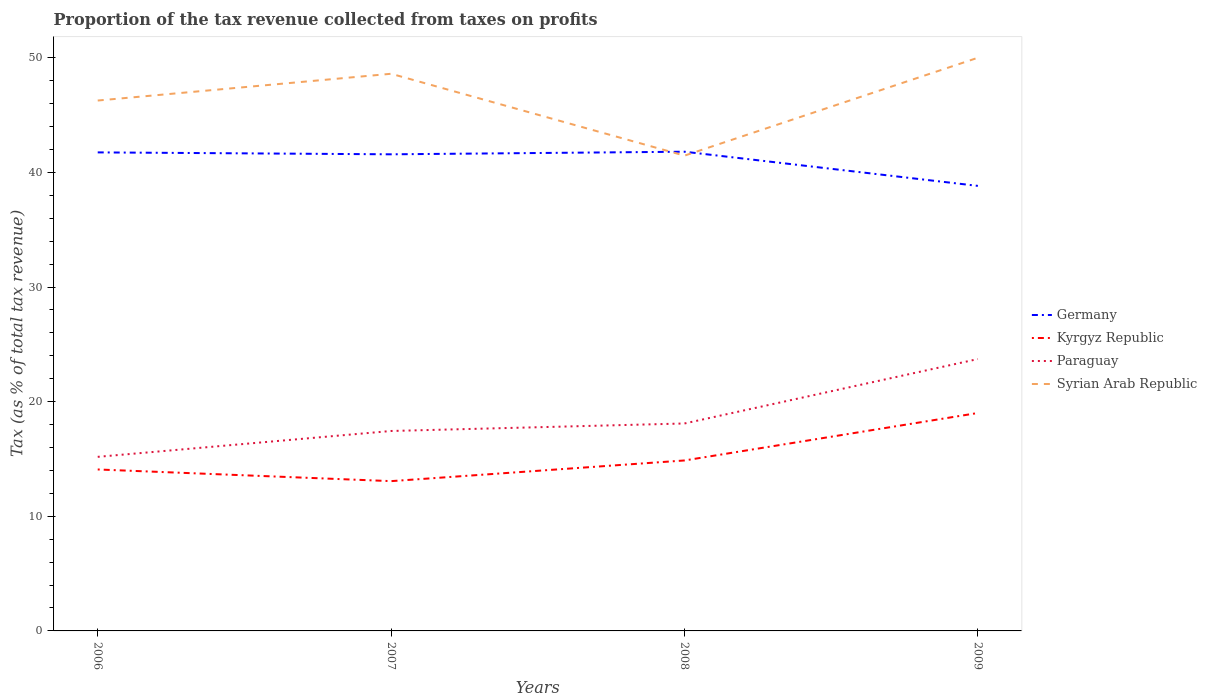Does the line corresponding to Syrian Arab Republic intersect with the line corresponding to Kyrgyz Republic?
Keep it short and to the point. No. Is the number of lines equal to the number of legend labels?
Provide a succinct answer. Yes. Across all years, what is the maximum proportion of the tax revenue collected in Paraguay?
Your answer should be compact. 15.19. In which year was the proportion of the tax revenue collected in Germany maximum?
Offer a terse response. 2009. What is the total proportion of the tax revenue collected in Kyrgyz Republic in the graph?
Your answer should be very brief. 1.02. What is the difference between the highest and the second highest proportion of the tax revenue collected in Syrian Arab Republic?
Give a very brief answer. 8.54. Is the proportion of the tax revenue collected in Paraguay strictly greater than the proportion of the tax revenue collected in Kyrgyz Republic over the years?
Make the answer very short. No. Are the values on the major ticks of Y-axis written in scientific E-notation?
Offer a terse response. No. Does the graph contain any zero values?
Offer a very short reply. No. Where does the legend appear in the graph?
Provide a succinct answer. Center right. How many legend labels are there?
Provide a succinct answer. 4. What is the title of the graph?
Your answer should be very brief. Proportion of the tax revenue collected from taxes on profits. What is the label or title of the X-axis?
Your response must be concise. Years. What is the label or title of the Y-axis?
Your answer should be compact. Tax (as % of total tax revenue). What is the Tax (as % of total tax revenue) of Germany in 2006?
Your answer should be very brief. 41.74. What is the Tax (as % of total tax revenue) in Kyrgyz Republic in 2006?
Ensure brevity in your answer.  14.08. What is the Tax (as % of total tax revenue) in Paraguay in 2006?
Ensure brevity in your answer.  15.19. What is the Tax (as % of total tax revenue) of Syrian Arab Republic in 2006?
Make the answer very short. 46.27. What is the Tax (as % of total tax revenue) in Germany in 2007?
Make the answer very short. 41.58. What is the Tax (as % of total tax revenue) of Kyrgyz Republic in 2007?
Keep it short and to the point. 13.07. What is the Tax (as % of total tax revenue) of Paraguay in 2007?
Your response must be concise. 17.44. What is the Tax (as % of total tax revenue) in Syrian Arab Republic in 2007?
Give a very brief answer. 48.6. What is the Tax (as % of total tax revenue) of Germany in 2008?
Provide a short and direct response. 41.8. What is the Tax (as % of total tax revenue) of Kyrgyz Republic in 2008?
Provide a succinct answer. 14.87. What is the Tax (as % of total tax revenue) in Paraguay in 2008?
Your answer should be very brief. 18.1. What is the Tax (as % of total tax revenue) in Syrian Arab Republic in 2008?
Your response must be concise. 41.46. What is the Tax (as % of total tax revenue) of Germany in 2009?
Make the answer very short. 38.82. What is the Tax (as % of total tax revenue) of Kyrgyz Republic in 2009?
Your answer should be compact. 19.01. What is the Tax (as % of total tax revenue) in Paraguay in 2009?
Your answer should be compact. 23.72. What is the Tax (as % of total tax revenue) in Syrian Arab Republic in 2009?
Give a very brief answer. 50. Across all years, what is the maximum Tax (as % of total tax revenue) of Germany?
Offer a terse response. 41.8. Across all years, what is the maximum Tax (as % of total tax revenue) of Kyrgyz Republic?
Ensure brevity in your answer.  19.01. Across all years, what is the maximum Tax (as % of total tax revenue) of Paraguay?
Keep it short and to the point. 23.72. Across all years, what is the maximum Tax (as % of total tax revenue) of Syrian Arab Republic?
Make the answer very short. 50. Across all years, what is the minimum Tax (as % of total tax revenue) of Germany?
Make the answer very short. 38.82. Across all years, what is the minimum Tax (as % of total tax revenue) of Kyrgyz Republic?
Your answer should be compact. 13.07. Across all years, what is the minimum Tax (as % of total tax revenue) in Paraguay?
Keep it short and to the point. 15.19. Across all years, what is the minimum Tax (as % of total tax revenue) of Syrian Arab Republic?
Keep it short and to the point. 41.46. What is the total Tax (as % of total tax revenue) of Germany in the graph?
Provide a succinct answer. 163.95. What is the total Tax (as % of total tax revenue) in Kyrgyz Republic in the graph?
Offer a very short reply. 61.03. What is the total Tax (as % of total tax revenue) in Paraguay in the graph?
Provide a succinct answer. 74.44. What is the total Tax (as % of total tax revenue) in Syrian Arab Republic in the graph?
Your answer should be very brief. 186.33. What is the difference between the Tax (as % of total tax revenue) of Germany in 2006 and that in 2007?
Keep it short and to the point. 0.17. What is the difference between the Tax (as % of total tax revenue) in Kyrgyz Republic in 2006 and that in 2007?
Offer a very short reply. 1.02. What is the difference between the Tax (as % of total tax revenue) of Paraguay in 2006 and that in 2007?
Offer a terse response. -2.26. What is the difference between the Tax (as % of total tax revenue) in Syrian Arab Republic in 2006 and that in 2007?
Offer a very short reply. -2.34. What is the difference between the Tax (as % of total tax revenue) in Germany in 2006 and that in 2008?
Your answer should be very brief. -0.06. What is the difference between the Tax (as % of total tax revenue) of Kyrgyz Republic in 2006 and that in 2008?
Make the answer very short. -0.79. What is the difference between the Tax (as % of total tax revenue) in Paraguay in 2006 and that in 2008?
Offer a terse response. -2.91. What is the difference between the Tax (as % of total tax revenue) of Syrian Arab Republic in 2006 and that in 2008?
Offer a terse response. 4.81. What is the difference between the Tax (as % of total tax revenue) of Germany in 2006 and that in 2009?
Make the answer very short. 2.92. What is the difference between the Tax (as % of total tax revenue) of Kyrgyz Republic in 2006 and that in 2009?
Provide a succinct answer. -4.93. What is the difference between the Tax (as % of total tax revenue) of Paraguay in 2006 and that in 2009?
Provide a succinct answer. -8.53. What is the difference between the Tax (as % of total tax revenue) in Syrian Arab Republic in 2006 and that in 2009?
Make the answer very short. -3.73. What is the difference between the Tax (as % of total tax revenue) of Germany in 2007 and that in 2008?
Your answer should be compact. -0.23. What is the difference between the Tax (as % of total tax revenue) of Kyrgyz Republic in 2007 and that in 2008?
Give a very brief answer. -1.8. What is the difference between the Tax (as % of total tax revenue) in Paraguay in 2007 and that in 2008?
Offer a very short reply. -0.65. What is the difference between the Tax (as % of total tax revenue) of Syrian Arab Republic in 2007 and that in 2008?
Your answer should be very brief. 7.14. What is the difference between the Tax (as % of total tax revenue) of Germany in 2007 and that in 2009?
Give a very brief answer. 2.75. What is the difference between the Tax (as % of total tax revenue) of Kyrgyz Republic in 2007 and that in 2009?
Your answer should be compact. -5.94. What is the difference between the Tax (as % of total tax revenue) in Paraguay in 2007 and that in 2009?
Offer a very short reply. -6.28. What is the difference between the Tax (as % of total tax revenue) in Syrian Arab Republic in 2007 and that in 2009?
Give a very brief answer. -1.4. What is the difference between the Tax (as % of total tax revenue) of Germany in 2008 and that in 2009?
Give a very brief answer. 2.98. What is the difference between the Tax (as % of total tax revenue) in Kyrgyz Republic in 2008 and that in 2009?
Keep it short and to the point. -4.14. What is the difference between the Tax (as % of total tax revenue) in Paraguay in 2008 and that in 2009?
Your answer should be very brief. -5.62. What is the difference between the Tax (as % of total tax revenue) in Syrian Arab Republic in 2008 and that in 2009?
Your response must be concise. -8.54. What is the difference between the Tax (as % of total tax revenue) of Germany in 2006 and the Tax (as % of total tax revenue) of Kyrgyz Republic in 2007?
Your response must be concise. 28.68. What is the difference between the Tax (as % of total tax revenue) in Germany in 2006 and the Tax (as % of total tax revenue) in Paraguay in 2007?
Provide a short and direct response. 24.3. What is the difference between the Tax (as % of total tax revenue) in Germany in 2006 and the Tax (as % of total tax revenue) in Syrian Arab Republic in 2007?
Offer a terse response. -6.86. What is the difference between the Tax (as % of total tax revenue) of Kyrgyz Republic in 2006 and the Tax (as % of total tax revenue) of Paraguay in 2007?
Keep it short and to the point. -3.36. What is the difference between the Tax (as % of total tax revenue) of Kyrgyz Republic in 2006 and the Tax (as % of total tax revenue) of Syrian Arab Republic in 2007?
Offer a terse response. -34.52. What is the difference between the Tax (as % of total tax revenue) of Paraguay in 2006 and the Tax (as % of total tax revenue) of Syrian Arab Republic in 2007?
Your response must be concise. -33.42. What is the difference between the Tax (as % of total tax revenue) in Germany in 2006 and the Tax (as % of total tax revenue) in Kyrgyz Republic in 2008?
Provide a short and direct response. 26.87. What is the difference between the Tax (as % of total tax revenue) in Germany in 2006 and the Tax (as % of total tax revenue) in Paraguay in 2008?
Your answer should be compact. 23.65. What is the difference between the Tax (as % of total tax revenue) in Germany in 2006 and the Tax (as % of total tax revenue) in Syrian Arab Republic in 2008?
Provide a succinct answer. 0.28. What is the difference between the Tax (as % of total tax revenue) in Kyrgyz Republic in 2006 and the Tax (as % of total tax revenue) in Paraguay in 2008?
Provide a short and direct response. -4.01. What is the difference between the Tax (as % of total tax revenue) of Kyrgyz Republic in 2006 and the Tax (as % of total tax revenue) of Syrian Arab Republic in 2008?
Give a very brief answer. -27.38. What is the difference between the Tax (as % of total tax revenue) of Paraguay in 2006 and the Tax (as % of total tax revenue) of Syrian Arab Republic in 2008?
Ensure brevity in your answer.  -26.28. What is the difference between the Tax (as % of total tax revenue) of Germany in 2006 and the Tax (as % of total tax revenue) of Kyrgyz Republic in 2009?
Your response must be concise. 22.73. What is the difference between the Tax (as % of total tax revenue) of Germany in 2006 and the Tax (as % of total tax revenue) of Paraguay in 2009?
Your answer should be compact. 18.03. What is the difference between the Tax (as % of total tax revenue) in Germany in 2006 and the Tax (as % of total tax revenue) in Syrian Arab Republic in 2009?
Provide a short and direct response. -8.26. What is the difference between the Tax (as % of total tax revenue) of Kyrgyz Republic in 2006 and the Tax (as % of total tax revenue) of Paraguay in 2009?
Your answer should be very brief. -9.63. What is the difference between the Tax (as % of total tax revenue) of Kyrgyz Republic in 2006 and the Tax (as % of total tax revenue) of Syrian Arab Republic in 2009?
Keep it short and to the point. -35.92. What is the difference between the Tax (as % of total tax revenue) in Paraguay in 2006 and the Tax (as % of total tax revenue) in Syrian Arab Republic in 2009?
Make the answer very short. -34.82. What is the difference between the Tax (as % of total tax revenue) in Germany in 2007 and the Tax (as % of total tax revenue) in Kyrgyz Republic in 2008?
Your answer should be very brief. 26.71. What is the difference between the Tax (as % of total tax revenue) of Germany in 2007 and the Tax (as % of total tax revenue) of Paraguay in 2008?
Your answer should be compact. 23.48. What is the difference between the Tax (as % of total tax revenue) in Germany in 2007 and the Tax (as % of total tax revenue) in Syrian Arab Republic in 2008?
Make the answer very short. 0.12. What is the difference between the Tax (as % of total tax revenue) of Kyrgyz Republic in 2007 and the Tax (as % of total tax revenue) of Paraguay in 2008?
Provide a succinct answer. -5.03. What is the difference between the Tax (as % of total tax revenue) of Kyrgyz Republic in 2007 and the Tax (as % of total tax revenue) of Syrian Arab Republic in 2008?
Your answer should be very brief. -28.39. What is the difference between the Tax (as % of total tax revenue) in Paraguay in 2007 and the Tax (as % of total tax revenue) in Syrian Arab Republic in 2008?
Ensure brevity in your answer.  -24.02. What is the difference between the Tax (as % of total tax revenue) in Germany in 2007 and the Tax (as % of total tax revenue) in Kyrgyz Republic in 2009?
Your answer should be very brief. 22.57. What is the difference between the Tax (as % of total tax revenue) of Germany in 2007 and the Tax (as % of total tax revenue) of Paraguay in 2009?
Your answer should be compact. 17.86. What is the difference between the Tax (as % of total tax revenue) in Germany in 2007 and the Tax (as % of total tax revenue) in Syrian Arab Republic in 2009?
Provide a short and direct response. -8.42. What is the difference between the Tax (as % of total tax revenue) of Kyrgyz Republic in 2007 and the Tax (as % of total tax revenue) of Paraguay in 2009?
Your response must be concise. -10.65. What is the difference between the Tax (as % of total tax revenue) in Kyrgyz Republic in 2007 and the Tax (as % of total tax revenue) in Syrian Arab Republic in 2009?
Offer a terse response. -36.93. What is the difference between the Tax (as % of total tax revenue) in Paraguay in 2007 and the Tax (as % of total tax revenue) in Syrian Arab Republic in 2009?
Your answer should be very brief. -32.56. What is the difference between the Tax (as % of total tax revenue) in Germany in 2008 and the Tax (as % of total tax revenue) in Kyrgyz Republic in 2009?
Your answer should be compact. 22.79. What is the difference between the Tax (as % of total tax revenue) of Germany in 2008 and the Tax (as % of total tax revenue) of Paraguay in 2009?
Make the answer very short. 18.09. What is the difference between the Tax (as % of total tax revenue) of Germany in 2008 and the Tax (as % of total tax revenue) of Syrian Arab Republic in 2009?
Make the answer very short. -8.2. What is the difference between the Tax (as % of total tax revenue) of Kyrgyz Republic in 2008 and the Tax (as % of total tax revenue) of Paraguay in 2009?
Give a very brief answer. -8.85. What is the difference between the Tax (as % of total tax revenue) of Kyrgyz Republic in 2008 and the Tax (as % of total tax revenue) of Syrian Arab Republic in 2009?
Ensure brevity in your answer.  -35.13. What is the difference between the Tax (as % of total tax revenue) in Paraguay in 2008 and the Tax (as % of total tax revenue) in Syrian Arab Republic in 2009?
Provide a short and direct response. -31.9. What is the average Tax (as % of total tax revenue) of Germany per year?
Your response must be concise. 40.99. What is the average Tax (as % of total tax revenue) of Kyrgyz Republic per year?
Provide a succinct answer. 15.26. What is the average Tax (as % of total tax revenue) of Paraguay per year?
Provide a succinct answer. 18.61. What is the average Tax (as % of total tax revenue) of Syrian Arab Republic per year?
Give a very brief answer. 46.58. In the year 2006, what is the difference between the Tax (as % of total tax revenue) in Germany and Tax (as % of total tax revenue) in Kyrgyz Republic?
Give a very brief answer. 27.66. In the year 2006, what is the difference between the Tax (as % of total tax revenue) in Germany and Tax (as % of total tax revenue) in Paraguay?
Provide a short and direct response. 26.56. In the year 2006, what is the difference between the Tax (as % of total tax revenue) of Germany and Tax (as % of total tax revenue) of Syrian Arab Republic?
Provide a succinct answer. -4.52. In the year 2006, what is the difference between the Tax (as % of total tax revenue) in Kyrgyz Republic and Tax (as % of total tax revenue) in Paraguay?
Provide a short and direct response. -1.1. In the year 2006, what is the difference between the Tax (as % of total tax revenue) in Kyrgyz Republic and Tax (as % of total tax revenue) in Syrian Arab Republic?
Offer a terse response. -32.18. In the year 2006, what is the difference between the Tax (as % of total tax revenue) in Paraguay and Tax (as % of total tax revenue) in Syrian Arab Republic?
Your response must be concise. -31.08. In the year 2007, what is the difference between the Tax (as % of total tax revenue) of Germany and Tax (as % of total tax revenue) of Kyrgyz Republic?
Your answer should be compact. 28.51. In the year 2007, what is the difference between the Tax (as % of total tax revenue) of Germany and Tax (as % of total tax revenue) of Paraguay?
Ensure brevity in your answer.  24.14. In the year 2007, what is the difference between the Tax (as % of total tax revenue) of Germany and Tax (as % of total tax revenue) of Syrian Arab Republic?
Keep it short and to the point. -7.03. In the year 2007, what is the difference between the Tax (as % of total tax revenue) of Kyrgyz Republic and Tax (as % of total tax revenue) of Paraguay?
Your response must be concise. -4.37. In the year 2007, what is the difference between the Tax (as % of total tax revenue) of Kyrgyz Republic and Tax (as % of total tax revenue) of Syrian Arab Republic?
Provide a short and direct response. -35.54. In the year 2007, what is the difference between the Tax (as % of total tax revenue) of Paraguay and Tax (as % of total tax revenue) of Syrian Arab Republic?
Provide a short and direct response. -31.16. In the year 2008, what is the difference between the Tax (as % of total tax revenue) in Germany and Tax (as % of total tax revenue) in Kyrgyz Republic?
Offer a terse response. 26.93. In the year 2008, what is the difference between the Tax (as % of total tax revenue) in Germany and Tax (as % of total tax revenue) in Paraguay?
Your answer should be very brief. 23.71. In the year 2008, what is the difference between the Tax (as % of total tax revenue) of Germany and Tax (as % of total tax revenue) of Syrian Arab Republic?
Offer a terse response. 0.34. In the year 2008, what is the difference between the Tax (as % of total tax revenue) of Kyrgyz Republic and Tax (as % of total tax revenue) of Paraguay?
Make the answer very short. -3.23. In the year 2008, what is the difference between the Tax (as % of total tax revenue) in Kyrgyz Republic and Tax (as % of total tax revenue) in Syrian Arab Republic?
Ensure brevity in your answer.  -26.59. In the year 2008, what is the difference between the Tax (as % of total tax revenue) in Paraguay and Tax (as % of total tax revenue) in Syrian Arab Republic?
Your answer should be very brief. -23.37. In the year 2009, what is the difference between the Tax (as % of total tax revenue) of Germany and Tax (as % of total tax revenue) of Kyrgyz Republic?
Your answer should be very brief. 19.81. In the year 2009, what is the difference between the Tax (as % of total tax revenue) of Germany and Tax (as % of total tax revenue) of Paraguay?
Your answer should be compact. 15.11. In the year 2009, what is the difference between the Tax (as % of total tax revenue) of Germany and Tax (as % of total tax revenue) of Syrian Arab Republic?
Give a very brief answer. -11.18. In the year 2009, what is the difference between the Tax (as % of total tax revenue) of Kyrgyz Republic and Tax (as % of total tax revenue) of Paraguay?
Your response must be concise. -4.71. In the year 2009, what is the difference between the Tax (as % of total tax revenue) of Kyrgyz Republic and Tax (as % of total tax revenue) of Syrian Arab Republic?
Your answer should be very brief. -30.99. In the year 2009, what is the difference between the Tax (as % of total tax revenue) in Paraguay and Tax (as % of total tax revenue) in Syrian Arab Republic?
Your answer should be compact. -26.28. What is the ratio of the Tax (as % of total tax revenue) in Germany in 2006 to that in 2007?
Make the answer very short. 1. What is the ratio of the Tax (as % of total tax revenue) in Kyrgyz Republic in 2006 to that in 2007?
Keep it short and to the point. 1.08. What is the ratio of the Tax (as % of total tax revenue) of Paraguay in 2006 to that in 2007?
Offer a terse response. 0.87. What is the ratio of the Tax (as % of total tax revenue) of Syrian Arab Republic in 2006 to that in 2007?
Offer a terse response. 0.95. What is the ratio of the Tax (as % of total tax revenue) in Germany in 2006 to that in 2008?
Provide a succinct answer. 1. What is the ratio of the Tax (as % of total tax revenue) of Kyrgyz Republic in 2006 to that in 2008?
Make the answer very short. 0.95. What is the ratio of the Tax (as % of total tax revenue) in Paraguay in 2006 to that in 2008?
Ensure brevity in your answer.  0.84. What is the ratio of the Tax (as % of total tax revenue) in Syrian Arab Republic in 2006 to that in 2008?
Give a very brief answer. 1.12. What is the ratio of the Tax (as % of total tax revenue) of Germany in 2006 to that in 2009?
Ensure brevity in your answer.  1.08. What is the ratio of the Tax (as % of total tax revenue) of Kyrgyz Republic in 2006 to that in 2009?
Offer a terse response. 0.74. What is the ratio of the Tax (as % of total tax revenue) in Paraguay in 2006 to that in 2009?
Give a very brief answer. 0.64. What is the ratio of the Tax (as % of total tax revenue) of Syrian Arab Republic in 2006 to that in 2009?
Provide a succinct answer. 0.93. What is the ratio of the Tax (as % of total tax revenue) of Germany in 2007 to that in 2008?
Ensure brevity in your answer.  0.99. What is the ratio of the Tax (as % of total tax revenue) in Kyrgyz Republic in 2007 to that in 2008?
Your answer should be compact. 0.88. What is the ratio of the Tax (as % of total tax revenue) of Paraguay in 2007 to that in 2008?
Your answer should be compact. 0.96. What is the ratio of the Tax (as % of total tax revenue) of Syrian Arab Republic in 2007 to that in 2008?
Provide a short and direct response. 1.17. What is the ratio of the Tax (as % of total tax revenue) in Germany in 2007 to that in 2009?
Your answer should be compact. 1.07. What is the ratio of the Tax (as % of total tax revenue) in Kyrgyz Republic in 2007 to that in 2009?
Make the answer very short. 0.69. What is the ratio of the Tax (as % of total tax revenue) of Paraguay in 2007 to that in 2009?
Keep it short and to the point. 0.74. What is the ratio of the Tax (as % of total tax revenue) in Syrian Arab Republic in 2007 to that in 2009?
Your answer should be compact. 0.97. What is the ratio of the Tax (as % of total tax revenue) in Germany in 2008 to that in 2009?
Your answer should be compact. 1.08. What is the ratio of the Tax (as % of total tax revenue) of Kyrgyz Republic in 2008 to that in 2009?
Ensure brevity in your answer.  0.78. What is the ratio of the Tax (as % of total tax revenue) of Paraguay in 2008 to that in 2009?
Provide a succinct answer. 0.76. What is the ratio of the Tax (as % of total tax revenue) of Syrian Arab Republic in 2008 to that in 2009?
Your answer should be compact. 0.83. What is the difference between the highest and the second highest Tax (as % of total tax revenue) in Germany?
Keep it short and to the point. 0.06. What is the difference between the highest and the second highest Tax (as % of total tax revenue) of Kyrgyz Republic?
Provide a short and direct response. 4.14. What is the difference between the highest and the second highest Tax (as % of total tax revenue) in Paraguay?
Provide a short and direct response. 5.62. What is the difference between the highest and the second highest Tax (as % of total tax revenue) of Syrian Arab Republic?
Keep it short and to the point. 1.4. What is the difference between the highest and the lowest Tax (as % of total tax revenue) in Germany?
Make the answer very short. 2.98. What is the difference between the highest and the lowest Tax (as % of total tax revenue) of Kyrgyz Republic?
Your answer should be compact. 5.94. What is the difference between the highest and the lowest Tax (as % of total tax revenue) in Paraguay?
Ensure brevity in your answer.  8.53. What is the difference between the highest and the lowest Tax (as % of total tax revenue) of Syrian Arab Republic?
Provide a short and direct response. 8.54. 